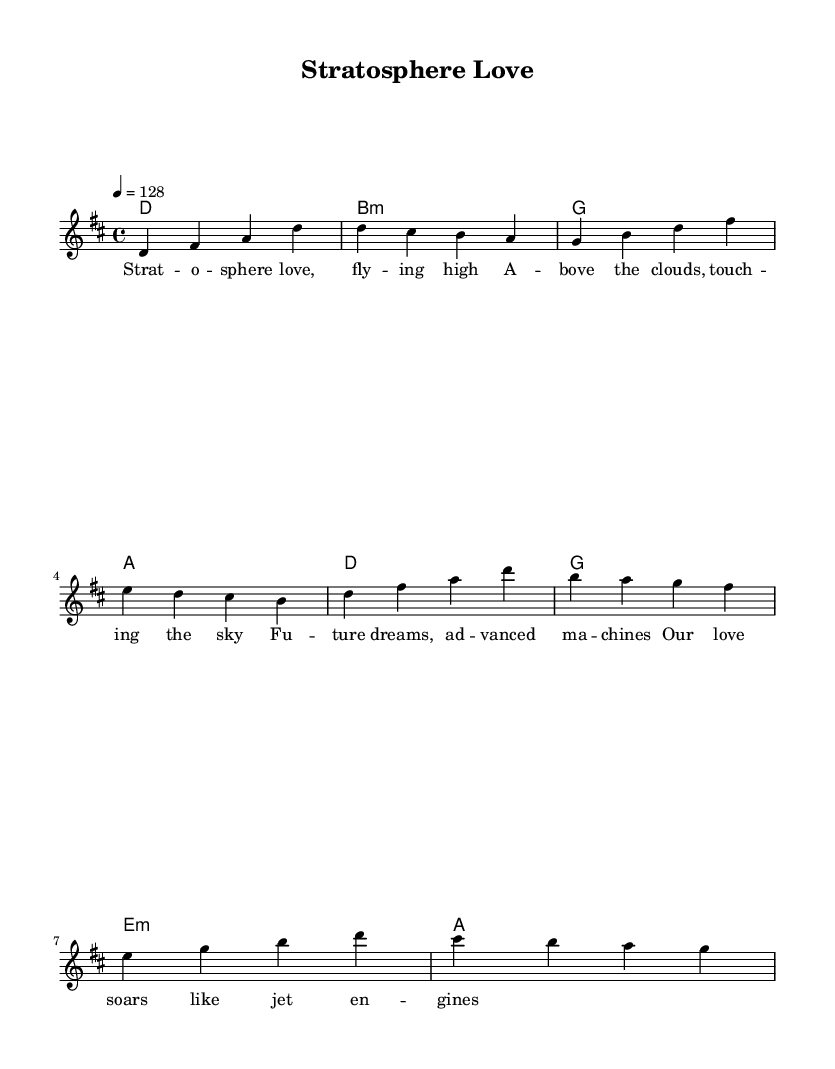What is the key signature of this music? The key signature indicates that the piece is in D major, which is represented by two sharps (F# and C#).
Answer: D major What is the time signature of this music? The time signature of the piece is 4/4, which means there are four beats in each measure, and the quarter note gets one beat.
Answer: 4/4 What is the tempo marking of this music? The tempo marking indicates that the piece should be played at a speed of 128 beats per minute, which is noted as "4 = 128".
Answer: 128 How many measures are in the verse section? By counting the measures written in the melody for the verse, we can see there are four measures in total.
Answer: 4 What is the first chord of the chorus? The first chord in the chorus is D major, as indicated in the harmonies section before the chorus melody begins.
Answer: D What do the lyrics suggest about the theme of this music? The lyrics indicate a theme of love and aspiration related to flight, using imagery of the stratosphere and jet engines.
Answer: Love and aspiration How does the overall structure of the song reflect typical K-Pop characteristics? The structure includes distinct verses and a chorus, which is common in K-Pop, highlighting catchy melodies and emotional themes.
Answer: Verses and a chorus 